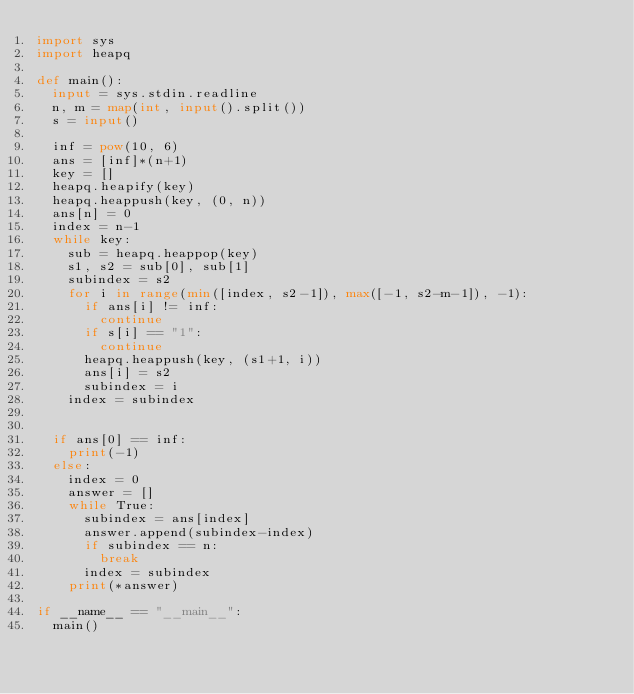Convert code to text. <code><loc_0><loc_0><loc_500><loc_500><_Python_>import sys
import heapq

def main():
  input = sys.stdin.readline
  n, m = map(int, input().split())
  s = input()
  
  inf = pow(10, 6)
  ans = [inf]*(n+1)
  key = []
  heapq.heapify(key)
  heapq.heappush(key, (0, n))
  ans[n] = 0
  index = n-1
  while key:
    sub = heapq.heappop(key)
    s1, s2 = sub[0], sub[1]
    subindex = s2
    for i in range(min([index, s2-1]), max([-1, s2-m-1]), -1):
      if ans[i] != inf:
        continue
      if s[i] == "1":
        continue
      heapq.heappush(key, (s1+1, i))
      ans[i] = s2
      subindex = i
    index = subindex
      
  
  if ans[0] == inf:
    print(-1)
  else:
    index = 0
    answer = []
    while True:
      subindex = ans[index]
      answer.append(subindex-index)
      if subindex == n:
        break
      index = subindex
    print(*answer)
  
if __name__ == "__main__":
  main()</code> 